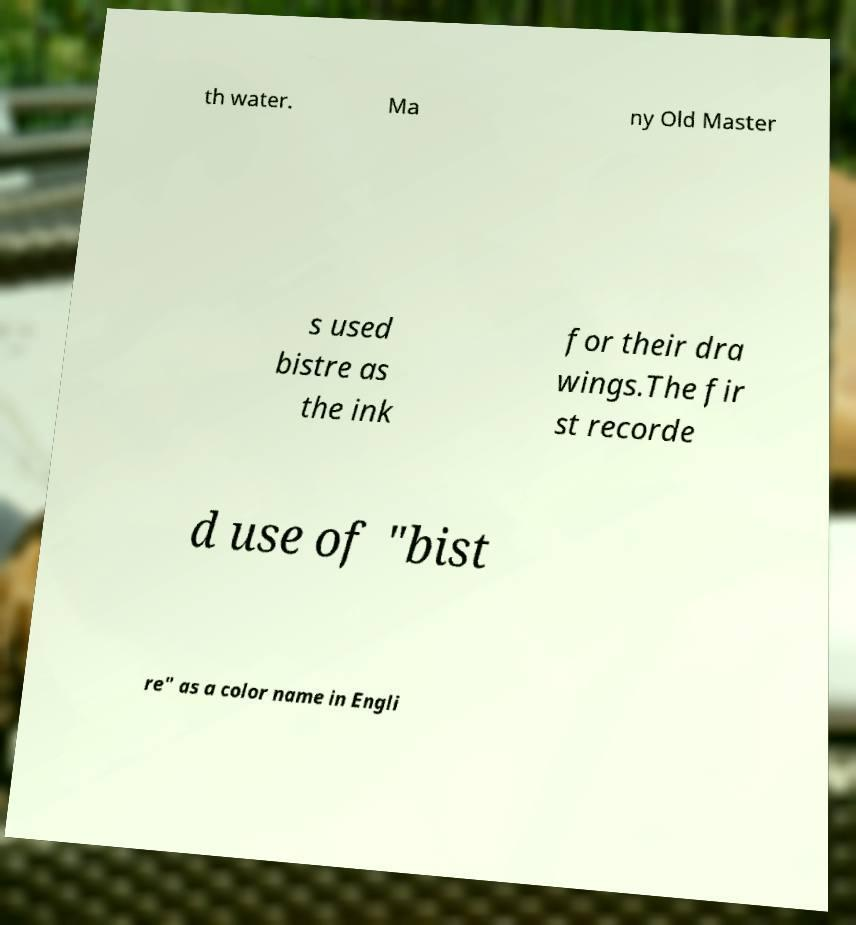What messages or text are displayed in this image? I need them in a readable, typed format. th water. Ma ny Old Master s used bistre as the ink for their dra wings.The fir st recorde d use of "bist re" as a color name in Engli 